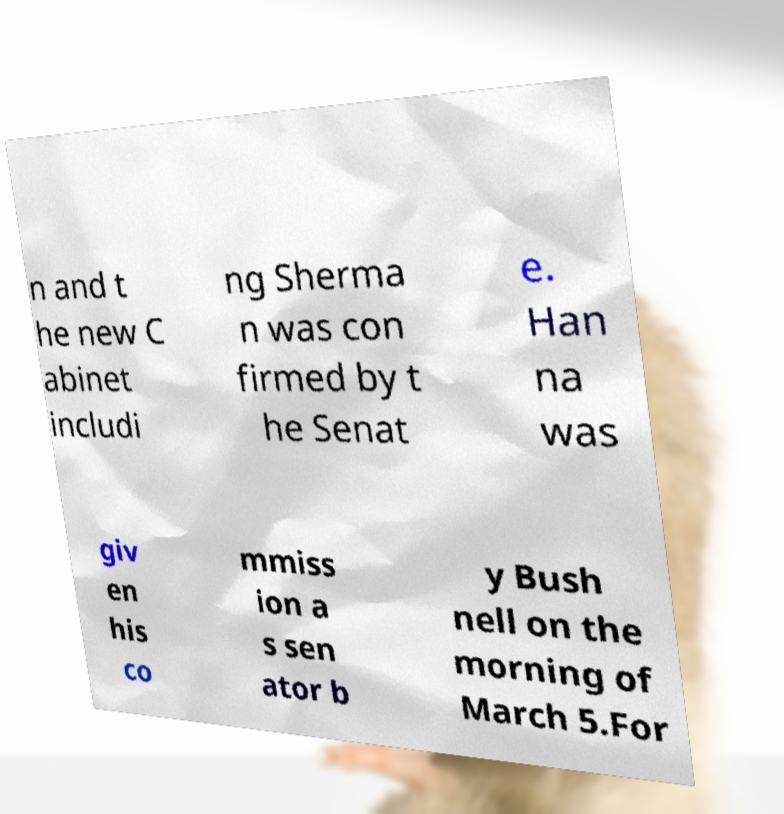Could you assist in decoding the text presented in this image and type it out clearly? n and t he new C abinet includi ng Sherma n was con firmed by t he Senat e. Han na was giv en his co mmiss ion a s sen ator b y Bush nell on the morning of March 5.For 